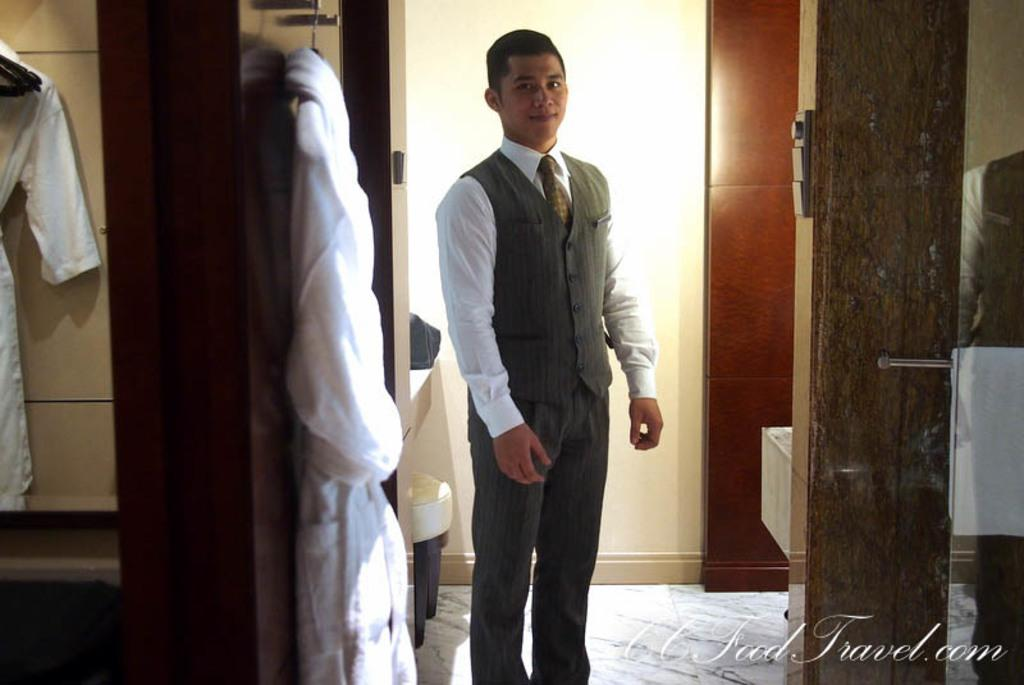What is the main subject of the image? There is a person standing in the image. Can you describe the person's attire? The person is wearing a white and grey color dress. What is visible in the background of the image? There is a wall in the image. What else can be seen in the image besides the person and the wall? Clothes are hanged on some objects in the image. What type of silk is being used to make the person's dress in the image? The facts provided do not mention the material of the dress, so we cannot determine if silk is being used. --- Facts: 1. There is a car in the image. 2. The car is red. 3. The car has four wheels. 4. There are people sitting inside the car. 5. The car has a sunroof. Absurd Topics: parrot, dance, ocean Conversation: What is the main subject of the image? There is a car in the image. Can you describe the car's color? The car is red. How many wheels does the car have? The car has four wheels. What can be seen inside the car? There are people sitting inside the car. What feature does the car have on its roof? The car has a sunroof. Reasoning: Let's think step by step in order to produce the conversation. We start by identifying the main subject of the image, which is the car. Then, we describe the car's color and the number of wheels it has. Next, we mention the people sitting inside the car. Finally, we focus on a specific feature of the car, which is the sunroof. Absurd Question/Answer: Can you tell me how many parrots are sitting on the car's sunroof in the image? There are no parrots present in the image, so we cannot determine the number of parrots on the sunroof. 